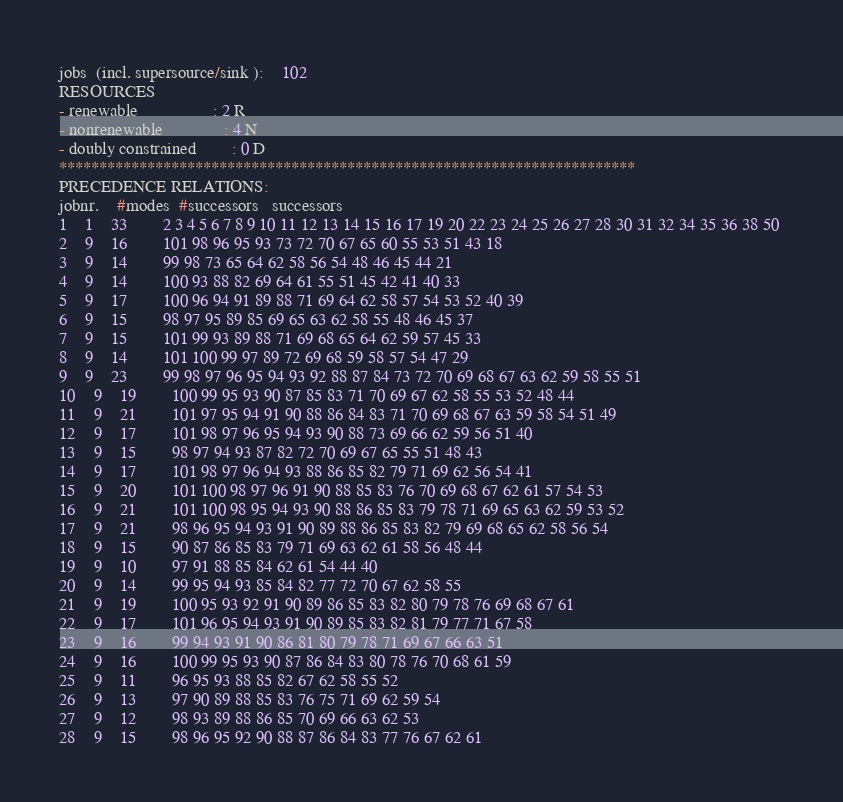Convert code to text. <code><loc_0><loc_0><loc_500><loc_500><_ObjectiveC_>jobs  (incl. supersource/sink ):	102
RESOURCES
- renewable                 : 2 R
- nonrenewable              : 4 N
- doubly constrained        : 0 D
************************************************************************
PRECEDENCE RELATIONS:
jobnr.    #modes  #successors   successors
1	1	33		2 3 4 5 6 7 8 9 10 11 12 13 14 15 16 17 19 20 22 23 24 25 26 27 28 30 31 32 34 35 36 38 50 
2	9	16		101 98 96 95 93 73 72 70 67 65 60 55 53 51 43 18 
3	9	14		99 98 73 65 64 62 58 56 54 48 46 45 44 21 
4	9	14		100 93 88 82 69 64 61 55 51 45 42 41 40 33 
5	9	17		100 96 94 91 89 88 71 69 64 62 58 57 54 53 52 40 39 
6	9	15		98 97 95 89 85 69 65 63 62 58 55 48 46 45 37 
7	9	15		101 99 93 89 88 71 69 68 65 64 62 59 57 45 33 
8	9	14		101 100 99 97 89 72 69 68 59 58 57 54 47 29 
9	9	23		99 98 97 96 95 94 93 92 88 87 84 73 72 70 69 68 67 63 62 59 58 55 51 
10	9	19		100 99 95 93 90 87 85 83 71 70 69 67 62 58 55 53 52 48 44 
11	9	21		101 97 95 94 91 90 88 86 84 83 71 70 69 68 67 63 59 58 54 51 49 
12	9	17		101 98 97 96 95 94 93 90 88 73 69 66 62 59 56 51 40 
13	9	15		98 97 94 93 87 82 72 70 69 67 65 55 51 48 43 
14	9	17		101 98 97 96 94 93 88 86 85 82 79 71 69 62 56 54 41 
15	9	20		101 100 98 97 96 91 90 88 85 83 76 70 69 68 67 62 61 57 54 53 
16	9	21		101 100 98 95 94 93 90 88 86 85 83 79 78 71 69 65 63 62 59 53 52 
17	9	21		98 96 95 94 93 91 90 89 88 86 85 83 82 79 69 68 65 62 58 56 54 
18	9	15		90 87 86 85 83 79 71 69 63 62 61 58 56 48 44 
19	9	10		97 91 88 85 84 62 61 54 44 40 
20	9	14		99 95 94 93 85 84 82 77 72 70 67 62 58 55 
21	9	19		100 95 93 92 91 90 89 86 85 83 82 80 79 78 76 69 68 67 61 
22	9	17		101 96 95 94 93 91 90 89 85 83 82 81 79 77 71 67 58 
23	9	16		99 94 93 91 90 86 81 80 79 78 71 69 67 66 63 51 
24	9	16		100 99 95 93 90 87 86 84 83 80 78 76 70 68 61 59 
25	9	11		96 95 93 88 85 82 67 62 58 55 52 
26	9	13		97 90 89 88 85 83 76 75 71 69 62 59 54 
27	9	12		98 93 89 88 86 85 70 69 66 63 62 53 
28	9	15		98 96 95 92 90 88 87 86 84 83 77 76 67 62 61 </code> 